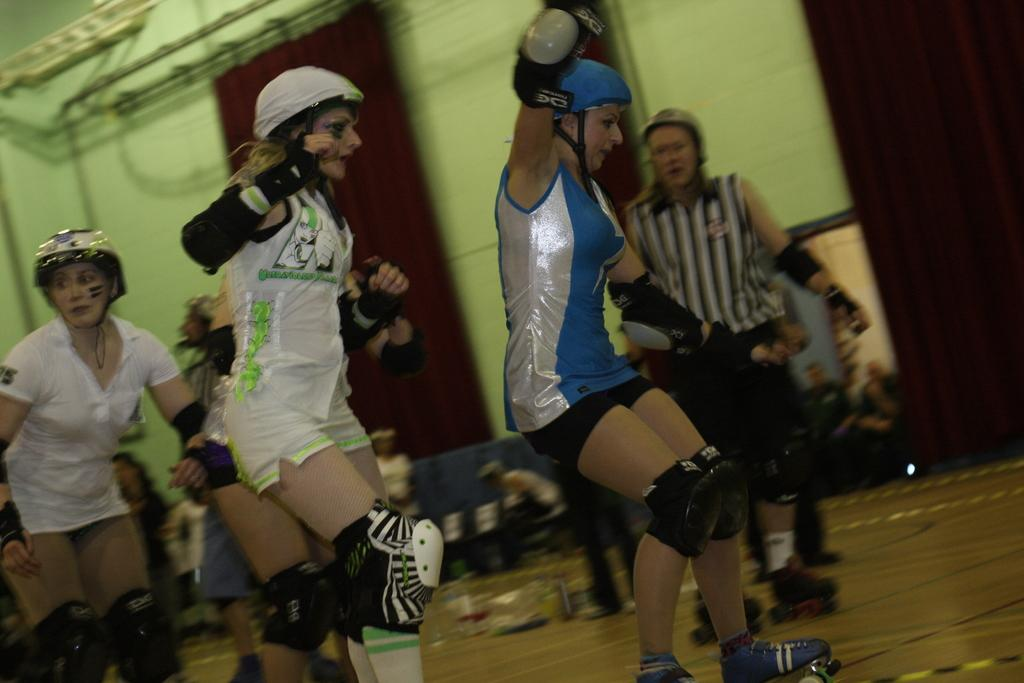What are the women in the image wearing on their heads? The women in the image are wearing helmets. What activity are the women engaged in? The women are skating on the floor. What can be seen in the background of the image? There are people sitting in the background of the image, as well as a wall. What objects are visible in the image that are not related to the women skating? There are rods visible in the image. What type of steam is being produced by the tramp in the image? There is no tramp or steam present in the image; the women are skating on the floor. 